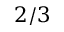Convert formula to latex. <formula><loc_0><loc_0><loc_500><loc_500>2 / 3</formula> 